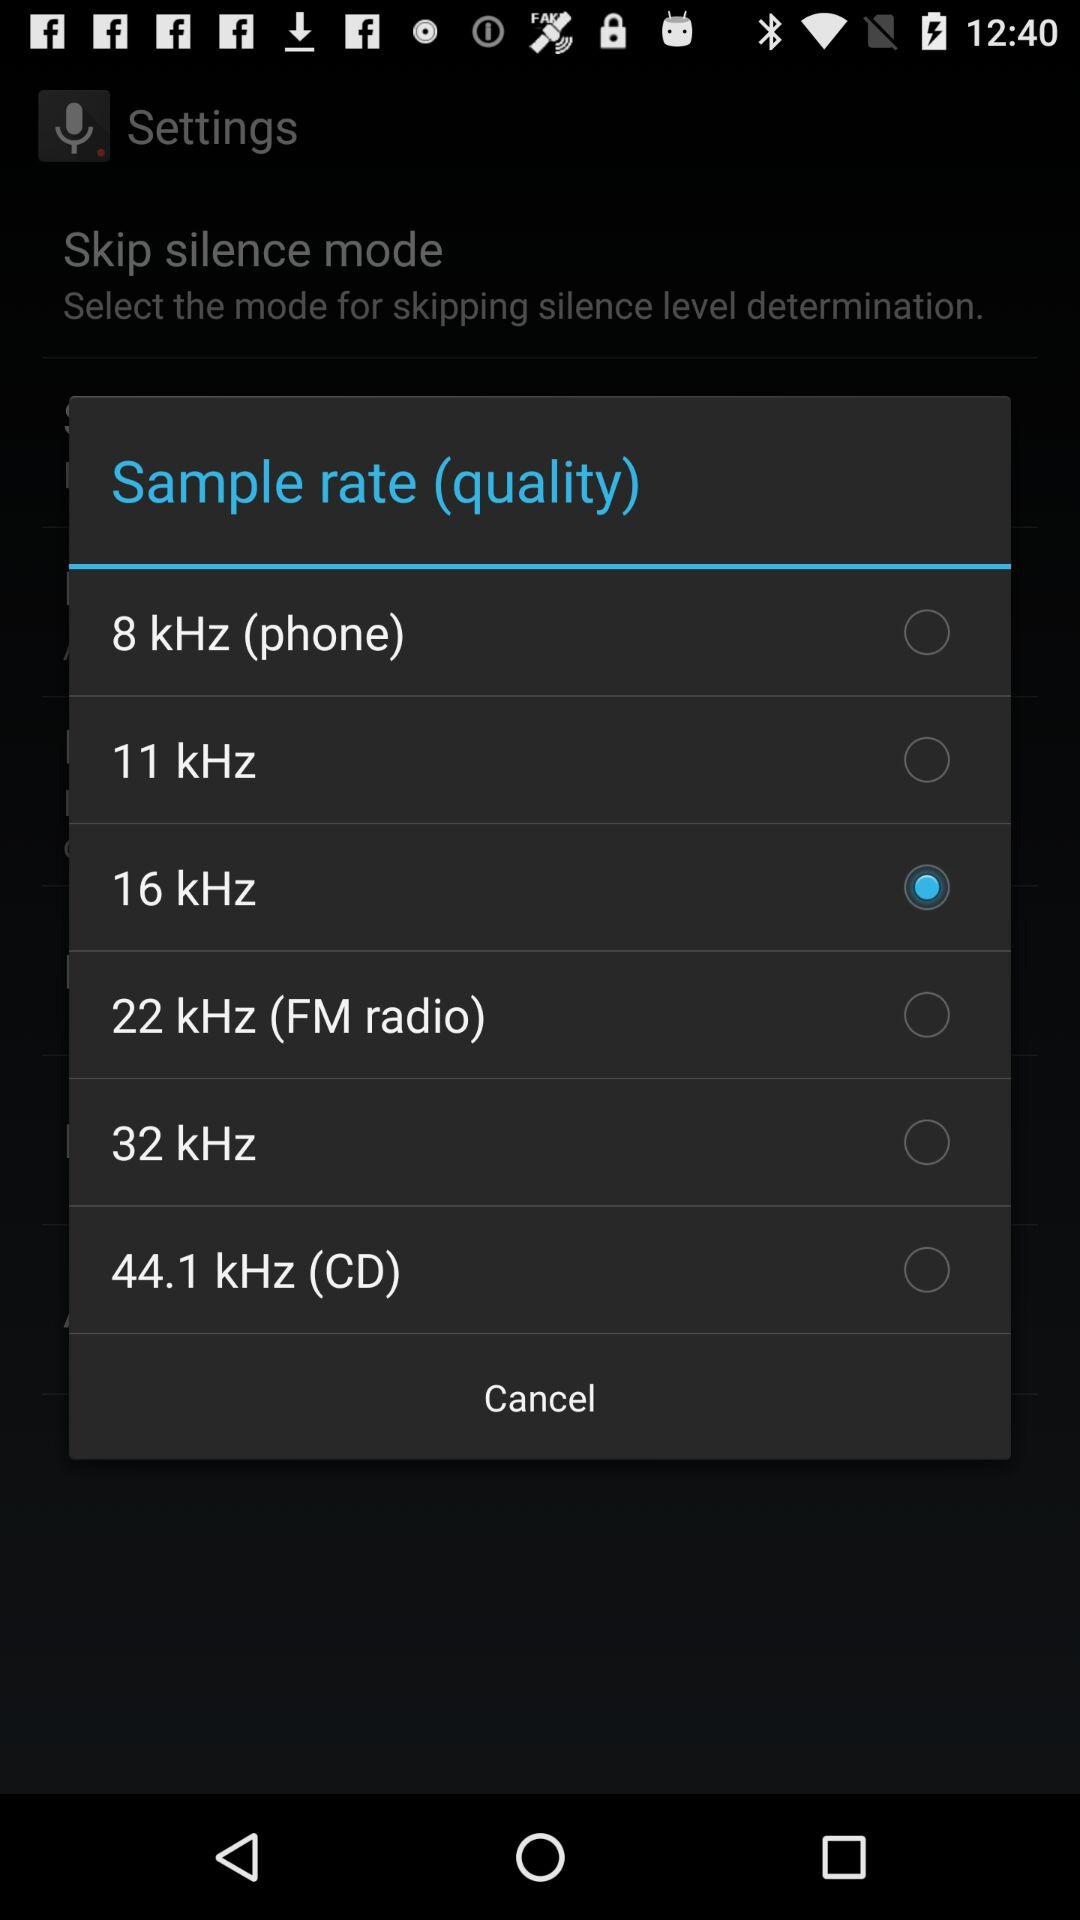Which sample rate (quality) is selected? The selected sample rate is 16 kHz. 